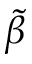<formula> <loc_0><loc_0><loc_500><loc_500>\tilde { \beta }</formula> 